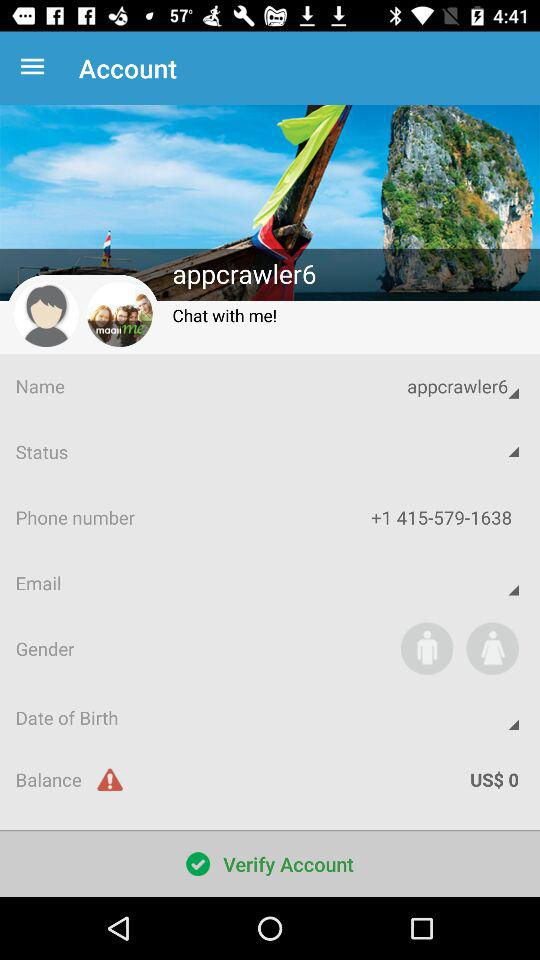What is the phone number shown on the screen? The phone number shown on the screen is +1 415-579-1638. 